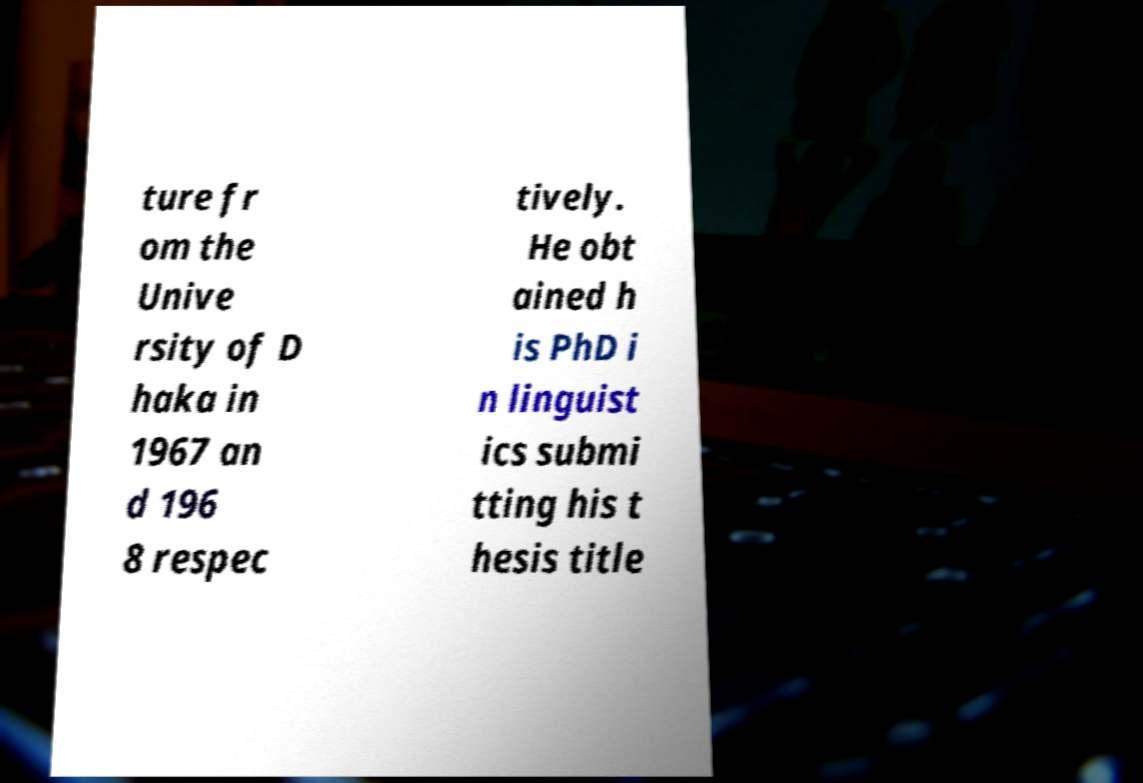Could you extract and type out the text from this image? ture fr om the Unive rsity of D haka in 1967 an d 196 8 respec tively. He obt ained h is PhD i n linguist ics submi tting his t hesis title 